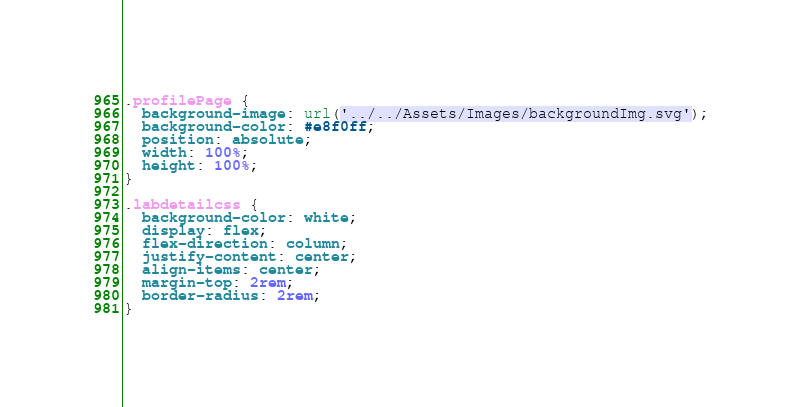Convert code to text. <code><loc_0><loc_0><loc_500><loc_500><_CSS_>.profilePage {
  background-image: url('../../Assets/Images/backgroundImg.svg');
  background-color: #e8f0ff;
  position: absolute;
  width: 100%;
  height: 100%;
}

.labdetailcss {
  background-color: white;
  display: flex;
  flex-direction: column;
  justify-content: center;
  align-items: center;
  margin-top: 2rem;
  border-radius: 2rem;
}
</code> 